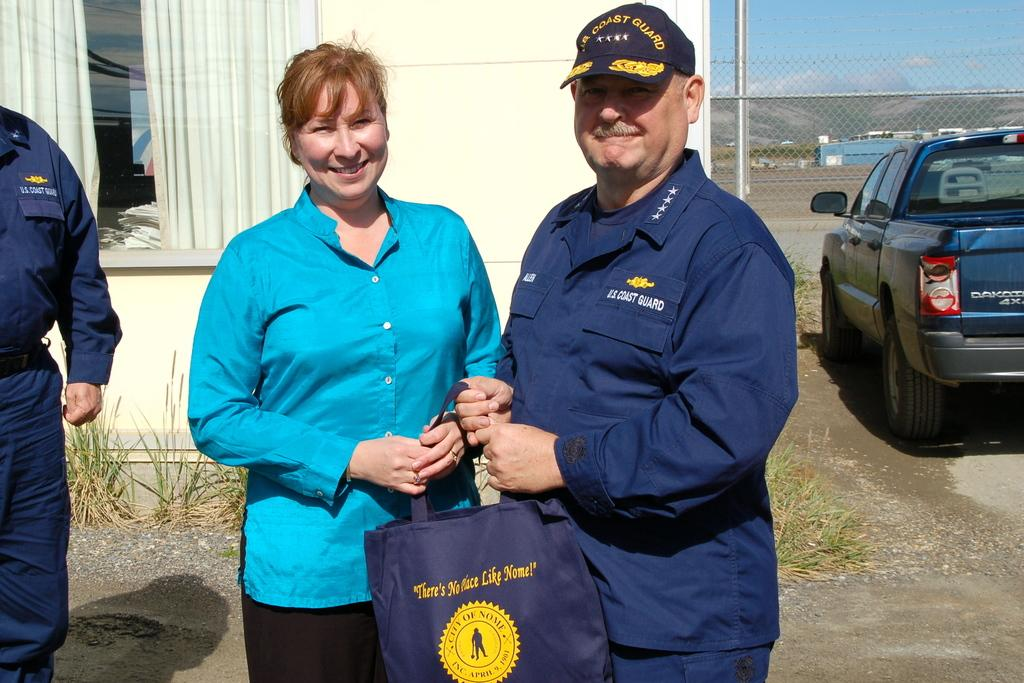What are the persons in the image holding? The persons in the image are holding an object. What type of covering can be seen in the image? There is a curtain in the image. What type of barrier is present in the image? There is fencing in the image. What type of transportation is visible in the image? There are vehicles in the image. What vertical structure is present in the image? There is a pole in the image. What type of vegetation is present in the image? Grass is present in the image. What part of the natural environment is visible in the image? The sky is visible in the image. What type of meal is being prepared by the woman in the image? There is no woman present in the image, and no meal preparation is depicted. What is the tendency of the objects in the image to move or change position? The objects in the image are stationary, and there is no indication of any tendency to move or change position. 